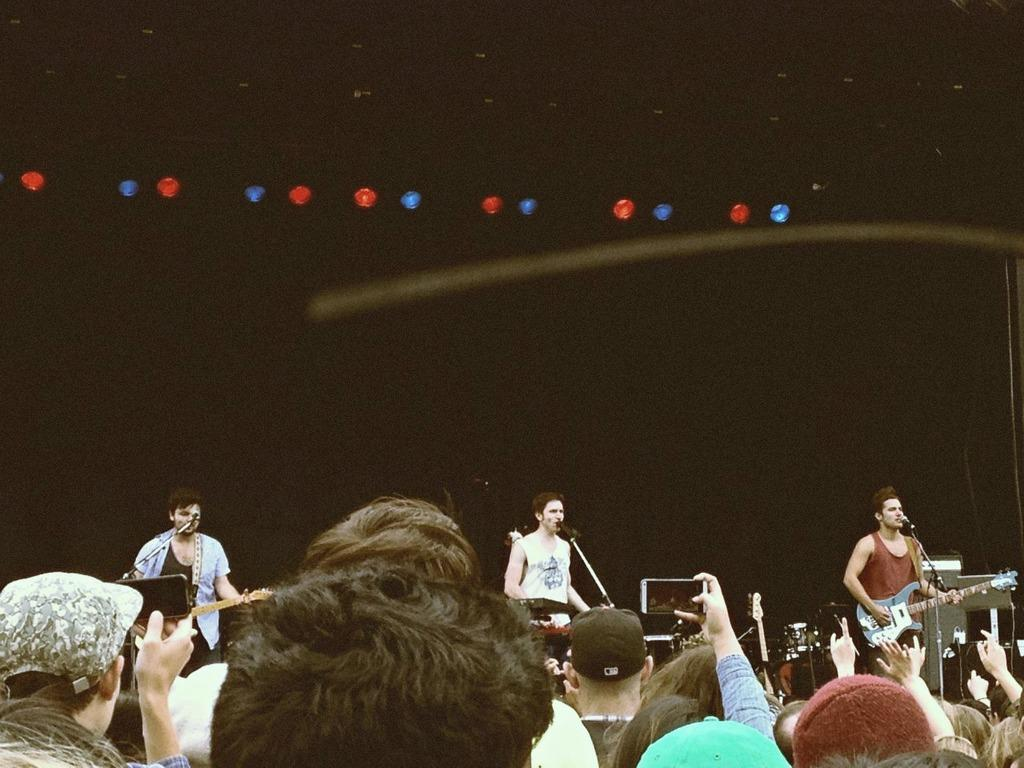What type of performance is happening on the stage? A rock band is performing on the stage. Who is the main vocalist in the performance? There is a man singing in the center of the stage. What instruments are being played by the band members? Two men are playing guitar on either side of the singer. What can be seen on top of the stage? There are lights on the top of the stage. Where is the audience located in relation to the stage? The crowd is in front of the stage. What type of truck can be seen driving across the grass in the image? There is no truck or grass present in the image; it features a rock band performing on a stage with a crowd in front of it. 